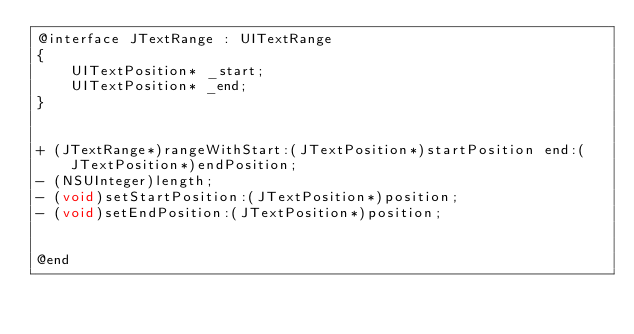Convert code to text. <code><loc_0><loc_0><loc_500><loc_500><_C_>@interface JTextRange : UITextRange
{
	UITextPosition* _start;
	UITextPosition* _end;
}


+ (JTextRange*)rangeWithStart:(JTextPosition*)startPosition end:(JTextPosition*)endPosition;
- (NSUInteger)length;
- (void)setStartPosition:(JTextPosition*)position;
- (void)setEndPosition:(JTextPosition*)position;


@end
</code> 